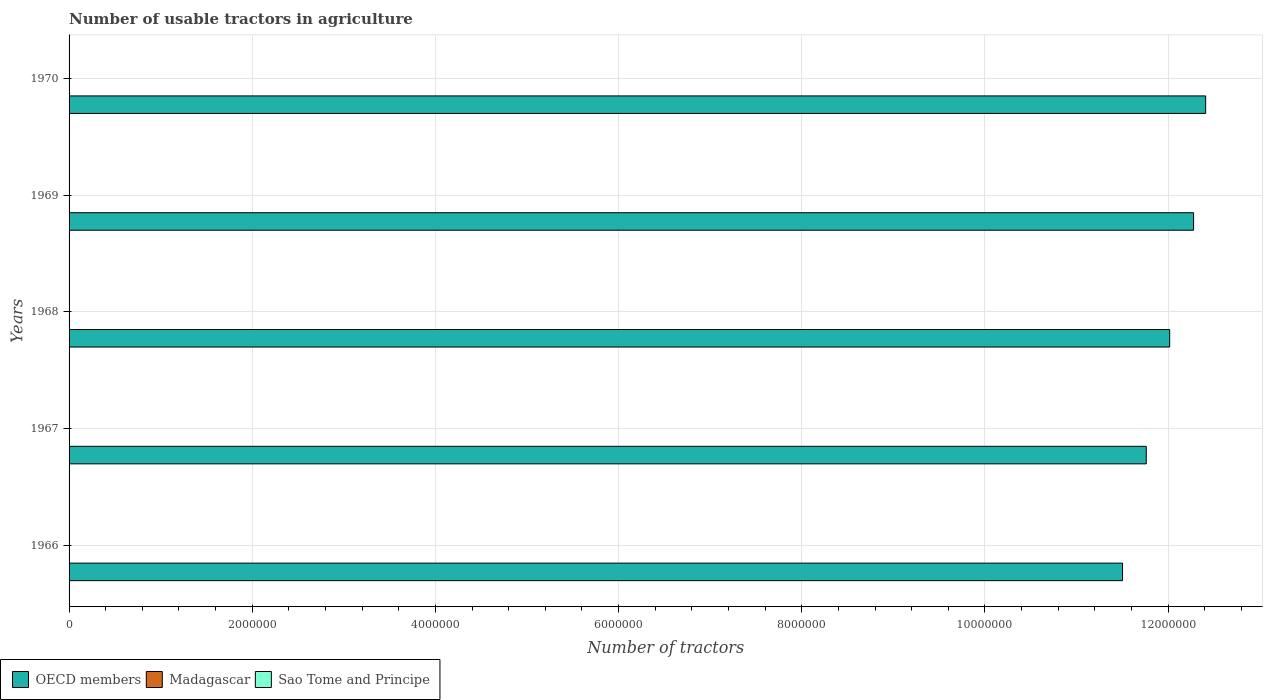How many different coloured bars are there?
Your response must be concise. 3. How many groups of bars are there?
Give a very brief answer. 5. Are the number of bars per tick equal to the number of legend labels?
Your answer should be compact. Yes. How many bars are there on the 1st tick from the bottom?
Offer a terse response. 3. What is the number of usable tractors in agriculture in Madagascar in 1969?
Provide a short and direct response. 2410. Across all years, what is the maximum number of usable tractors in agriculture in Sao Tome and Principe?
Give a very brief answer. 114. Across all years, what is the minimum number of usable tractors in agriculture in OECD members?
Make the answer very short. 1.15e+07. In which year was the number of usable tractors in agriculture in Sao Tome and Principe minimum?
Provide a succinct answer. 1966. What is the total number of usable tractors in agriculture in Madagascar in the graph?
Your answer should be compact. 1.11e+04. What is the difference between the number of usable tractors in agriculture in OECD members in 1970 and the number of usable tractors in agriculture in Madagascar in 1968?
Give a very brief answer. 1.24e+07. What is the average number of usable tractors in agriculture in Madagascar per year?
Offer a very short reply. 2223. In the year 1967, what is the difference between the number of usable tractors in agriculture in OECD members and number of usable tractors in agriculture in Madagascar?
Offer a terse response. 1.18e+07. What is the ratio of the number of usable tractors in agriculture in OECD members in 1968 to that in 1970?
Give a very brief answer. 0.97. Is the difference between the number of usable tractors in agriculture in OECD members in 1966 and 1968 greater than the difference between the number of usable tractors in agriculture in Madagascar in 1966 and 1968?
Provide a succinct answer. No. What is the difference between the highest and the second highest number of usable tractors in agriculture in Madagascar?
Your answer should be very brief. 5. What is the difference between the highest and the lowest number of usable tractors in agriculture in Madagascar?
Provide a short and direct response. 510. Is the sum of the number of usable tractors in agriculture in OECD members in 1967 and 1970 greater than the maximum number of usable tractors in agriculture in Madagascar across all years?
Your answer should be very brief. Yes. What does the 2nd bar from the top in 1967 represents?
Make the answer very short. Madagascar. What does the 1st bar from the bottom in 1969 represents?
Offer a terse response. OECD members. How many years are there in the graph?
Provide a short and direct response. 5. What is the difference between two consecutive major ticks on the X-axis?
Keep it short and to the point. 2.00e+06. Are the values on the major ticks of X-axis written in scientific E-notation?
Your response must be concise. No. Does the graph contain any zero values?
Provide a short and direct response. No. Does the graph contain grids?
Offer a terse response. Yes. Where does the legend appear in the graph?
Ensure brevity in your answer.  Bottom left. How many legend labels are there?
Provide a succinct answer. 3. How are the legend labels stacked?
Your answer should be compact. Horizontal. What is the title of the graph?
Make the answer very short. Number of usable tractors in agriculture. Does "Liechtenstein" appear as one of the legend labels in the graph?
Give a very brief answer. No. What is the label or title of the X-axis?
Offer a very short reply. Number of tractors. What is the Number of tractors of OECD members in 1966?
Keep it short and to the point. 1.15e+07. What is the Number of tractors of Madagascar in 1966?
Offer a terse response. 1900. What is the Number of tractors of Sao Tome and Principe in 1966?
Your answer should be compact. 60. What is the Number of tractors of OECD members in 1967?
Your answer should be very brief. 1.18e+07. What is the Number of tractors in Madagascar in 1967?
Ensure brevity in your answer.  2100. What is the Number of tractors of Sao Tome and Principe in 1967?
Provide a short and direct response. 80. What is the Number of tractors of OECD members in 1968?
Give a very brief answer. 1.20e+07. What is the Number of tractors of Madagascar in 1968?
Your response must be concise. 2300. What is the Number of tractors of Sao Tome and Principe in 1968?
Keep it short and to the point. 100. What is the Number of tractors of OECD members in 1969?
Provide a short and direct response. 1.23e+07. What is the Number of tractors of Madagascar in 1969?
Your answer should be very brief. 2410. What is the Number of tractors of Sao Tome and Principe in 1969?
Offer a terse response. 110. What is the Number of tractors of OECD members in 1970?
Your response must be concise. 1.24e+07. What is the Number of tractors of Madagascar in 1970?
Your answer should be very brief. 2405. What is the Number of tractors in Sao Tome and Principe in 1970?
Offer a terse response. 114. Across all years, what is the maximum Number of tractors in OECD members?
Make the answer very short. 1.24e+07. Across all years, what is the maximum Number of tractors of Madagascar?
Provide a succinct answer. 2410. Across all years, what is the maximum Number of tractors of Sao Tome and Principe?
Your answer should be compact. 114. Across all years, what is the minimum Number of tractors in OECD members?
Make the answer very short. 1.15e+07. Across all years, what is the minimum Number of tractors in Madagascar?
Provide a succinct answer. 1900. Across all years, what is the minimum Number of tractors of Sao Tome and Principe?
Keep it short and to the point. 60. What is the total Number of tractors in OECD members in the graph?
Your answer should be compact. 6.00e+07. What is the total Number of tractors of Madagascar in the graph?
Your answer should be very brief. 1.11e+04. What is the total Number of tractors in Sao Tome and Principe in the graph?
Offer a very short reply. 464. What is the difference between the Number of tractors of OECD members in 1966 and that in 1967?
Your answer should be very brief. -2.59e+05. What is the difference between the Number of tractors of Madagascar in 1966 and that in 1967?
Give a very brief answer. -200. What is the difference between the Number of tractors in OECD members in 1966 and that in 1968?
Your answer should be very brief. -5.15e+05. What is the difference between the Number of tractors in Madagascar in 1966 and that in 1968?
Offer a terse response. -400. What is the difference between the Number of tractors of OECD members in 1966 and that in 1969?
Your answer should be compact. -7.76e+05. What is the difference between the Number of tractors in Madagascar in 1966 and that in 1969?
Offer a very short reply. -510. What is the difference between the Number of tractors of Sao Tome and Principe in 1966 and that in 1969?
Your answer should be very brief. -50. What is the difference between the Number of tractors in OECD members in 1966 and that in 1970?
Offer a terse response. -9.08e+05. What is the difference between the Number of tractors of Madagascar in 1966 and that in 1970?
Make the answer very short. -505. What is the difference between the Number of tractors of Sao Tome and Principe in 1966 and that in 1970?
Provide a succinct answer. -54. What is the difference between the Number of tractors in OECD members in 1967 and that in 1968?
Give a very brief answer. -2.56e+05. What is the difference between the Number of tractors in Madagascar in 1967 and that in 1968?
Your answer should be very brief. -200. What is the difference between the Number of tractors in OECD members in 1967 and that in 1969?
Provide a short and direct response. -5.17e+05. What is the difference between the Number of tractors in Madagascar in 1967 and that in 1969?
Your response must be concise. -310. What is the difference between the Number of tractors in OECD members in 1967 and that in 1970?
Provide a short and direct response. -6.49e+05. What is the difference between the Number of tractors in Madagascar in 1967 and that in 1970?
Give a very brief answer. -305. What is the difference between the Number of tractors in Sao Tome and Principe in 1967 and that in 1970?
Ensure brevity in your answer.  -34. What is the difference between the Number of tractors of OECD members in 1968 and that in 1969?
Provide a short and direct response. -2.61e+05. What is the difference between the Number of tractors in Madagascar in 1968 and that in 1969?
Your response must be concise. -110. What is the difference between the Number of tractors in OECD members in 1968 and that in 1970?
Offer a terse response. -3.93e+05. What is the difference between the Number of tractors in Madagascar in 1968 and that in 1970?
Give a very brief answer. -105. What is the difference between the Number of tractors of OECD members in 1969 and that in 1970?
Keep it short and to the point. -1.32e+05. What is the difference between the Number of tractors in Madagascar in 1969 and that in 1970?
Make the answer very short. 5. What is the difference between the Number of tractors of OECD members in 1966 and the Number of tractors of Madagascar in 1967?
Provide a succinct answer. 1.15e+07. What is the difference between the Number of tractors in OECD members in 1966 and the Number of tractors in Sao Tome and Principe in 1967?
Offer a terse response. 1.15e+07. What is the difference between the Number of tractors of Madagascar in 1966 and the Number of tractors of Sao Tome and Principe in 1967?
Offer a terse response. 1820. What is the difference between the Number of tractors in OECD members in 1966 and the Number of tractors in Madagascar in 1968?
Provide a short and direct response. 1.15e+07. What is the difference between the Number of tractors in OECD members in 1966 and the Number of tractors in Sao Tome and Principe in 1968?
Provide a short and direct response. 1.15e+07. What is the difference between the Number of tractors of Madagascar in 1966 and the Number of tractors of Sao Tome and Principe in 1968?
Offer a terse response. 1800. What is the difference between the Number of tractors in OECD members in 1966 and the Number of tractors in Madagascar in 1969?
Your answer should be compact. 1.15e+07. What is the difference between the Number of tractors of OECD members in 1966 and the Number of tractors of Sao Tome and Principe in 1969?
Offer a terse response. 1.15e+07. What is the difference between the Number of tractors of Madagascar in 1966 and the Number of tractors of Sao Tome and Principe in 1969?
Keep it short and to the point. 1790. What is the difference between the Number of tractors in OECD members in 1966 and the Number of tractors in Madagascar in 1970?
Your answer should be compact. 1.15e+07. What is the difference between the Number of tractors in OECD members in 1966 and the Number of tractors in Sao Tome and Principe in 1970?
Offer a terse response. 1.15e+07. What is the difference between the Number of tractors in Madagascar in 1966 and the Number of tractors in Sao Tome and Principe in 1970?
Your response must be concise. 1786. What is the difference between the Number of tractors in OECD members in 1967 and the Number of tractors in Madagascar in 1968?
Make the answer very short. 1.18e+07. What is the difference between the Number of tractors of OECD members in 1967 and the Number of tractors of Sao Tome and Principe in 1968?
Your answer should be compact. 1.18e+07. What is the difference between the Number of tractors of Madagascar in 1967 and the Number of tractors of Sao Tome and Principe in 1968?
Keep it short and to the point. 2000. What is the difference between the Number of tractors in OECD members in 1967 and the Number of tractors in Madagascar in 1969?
Your answer should be very brief. 1.18e+07. What is the difference between the Number of tractors of OECD members in 1967 and the Number of tractors of Sao Tome and Principe in 1969?
Provide a short and direct response. 1.18e+07. What is the difference between the Number of tractors of Madagascar in 1967 and the Number of tractors of Sao Tome and Principe in 1969?
Provide a succinct answer. 1990. What is the difference between the Number of tractors in OECD members in 1967 and the Number of tractors in Madagascar in 1970?
Offer a terse response. 1.18e+07. What is the difference between the Number of tractors in OECD members in 1967 and the Number of tractors in Sao Tome and Principe in 1970?
Provide a succinct answer. 1.18e+07. What is the difference between the Number of tractors in Madagascar in 1967 and the Number of tractors in Sao Tome and Principe in 1970?
Make the answer very short. 1986. What is the difference between the Number of tractors of OECD members in 1968 and the Number of tractors of Madagascar in 1969?
Ensure brevity in your answer.  1.20e+07. What is the difference between the Number of tractors of OECD members in 1968 and the Number of tractors of Sao Tome and Principe in 1969?
Your response must be concise. 1.20e+07. What is the difference between the Number of tractors of Madagascar in 1968 and the Number of tractors of Sao Tome and Principe in 1969?
Give a very brief answer. 2190. What is the difference between the Number of tractors in OECD members in 1968 and the Number of tractors in Madagascar in 1970?
Your answer should be compact. 1.20e+07. What is the difference between the Number of tractors of OECD members in 1968 and the Number of tractors of Sao Tome and Principe in 1970?
Make the answer very short. 1.20e+07. What is the difference between the Number of tractors of Madagascar in 1968 and the Number of tractors of Sao Tome and Principe in 1970?
Make the answer very short. 2186. What is the difference between the Number of tractors of OECD members in 1969 and the Number of tractors of Madagascar in 1970?
Offer a very short reply. 1.23e+07. What is the difference between the Number of tractors of OECD members in 1969 and the Number of tractors of Sao Tome and Principe in 1970?
Your answer should be very brief. 1.23e+07. What is the difference between the Number of tractors in Madagascar in 1969 and the Number of tractors in Sao Tome and Principe in 1970?
Your answer should be very brief. 2296. What is the average Number of tractors in OECD members per year?
Offer a terse response. 1.20e+07. What is the average Number of tractors of Madagascar per year?
Offer a very short reply. 2223. What is the average Number of tractors in Sao Tome and Principe per year?
Ensure brevity in your answer.  92.8. In the year 1966, what is the difference between the Number of tractors in OECD members and Number of tractors in Madagascar?
Make the answer very short. 1.15e+07. In the year 1966, what is the difference between the Number of tractors in OECD members and Number of tractors in Sao Tome and Principe?
Provide a short and direct response. 1.15e+07. In the year 1966, what is the difference between the Number of tractors in Madagascar and Number of tractors in Sao Tome and Principe?
Offer a terse response. 1840. In the year 1967, what is the difference between the Number of tractors of OECD members and Number of tractors of Madagascar?
Your answer should be very brief. 1.18e+07. In the year 1967, what is the difference between the Number of tractors in OECD members and Number of tractors in Sao Tome and Principe?
Provide a succinct answer. 1.18e+07. In the year 1967, what is the difference between the Number of tractors of Madagascar and Number of tractors of Sao Tome and Principe?
Your answer should be compact. 2020. In the year 1968, what is the difference between the Number of tractors of OECD members and Number of tractors of Madagascar?
Your answer should be compact. 1.20e+07. In the year 1968, what is the difference between the Number of tractors of OECD members and Number of tractors of Sao Tome and Principe?
Make the answer very short. 1.20e+07. In the year 1968, what is the difference between the Number of tractors in Madagascar and Number of tractors in Sao Tome and Principe?
Offer a terse response. 2200. In the year 1969, what is the difference between the Number of tractors in OECD members and Number of tractors in Madagascar?
Offer a terse response. 1.23e+07. In the year 1969, what is the difference between the Number of tractors of OECD members and Number of tractors of Sao Tome and Principe?
Ensure brevity in your answer.  1.23e+07. In the year 1969, what is the difference between the Number of tractors in Madagascar and Number of tractors in Sao Tome and Principe?
Provide a short and direct response. 2300. In the year 1970, what is the difference between the Number of tractors of OECD members and Number of tractors of Madagascar?
Provide a succinct answer. 1.24e+07. In the year 1970, what is the difference between the Number of tractors in OECD members and Number of tractors in Sao Tome and Principe?
Give a very brief answer. 1.24e+07. In the year 1970, what is the difference between the Number of tractors of Madagascar and Number of tractors of Sao Tome and Principe?
Keep it short and to the point. 2291. What is the ratio of the Number of tractors in OECD members in 1966 to that in 1967?
Your answer should be very brief. 0.98. What is the ratio of the Number of tractors of Madagascar in 1966 to that in 1967?
Your response must be concise. 0.9. What is the ratio of the Number of tractors in Sao Tome and Principe in 1966 to that in 1967?
Your answer should be very brief. 0.75. What is the ratio of the Number of tractors of OECD members in 1966 to that in 1968?
Your answer should be compact. 0.96. What is the ratio of the Number of tractors in Madagascar in 1966 to that in 1968?
Offer a very short reply. 0.83. What is the ratio of the Number of tractors in OECD members in 1966 to that in 1969?
Make the answer very short. 0.94. What is the ratio of the Number of tractors of Madagascar in 1966 to that in 1969?
Ensure brevity in your answer.  0.79. What is the ratio of the Number of tractors in Sao Tome and Principe in 1966 to that in 1969?
Ensure brevity in your answer.  0.55. What is the ratio of the Number of tractors in OECD members in 1966 to that in 1970?
Give a very brief answer. 0.93. What is the ratio of the Number of tractors of Madagascar in 1966 to that in 1970?
Keep it short and to the point. 0.79. What is the ratio of the Number of tractors in Sao Tome and Principe in 1966 to that in 1970?
Give a very brief answer. 0.53. What is the ratio of the Number of tractors of OECD members in 1967 to that in 1968?
Give a very brief answer. 0.98. What is the ratio of the Number of tractors of Madagascar in 1967 to that in 1968?
Your answer should be very brief. 0.91. What is the ratio of the Number of tractors in OECD members in 1967 to that in 1969?
Offer a terse response. 0.96. What is the ratio of the Number of tractors in Madagascar in 1967 to that in 1969?
Provide a short and direct response. 0.87. What is the ratio of the Number of tractors in Sao Tome and Principe in 1967 to that in 1969?
Your answer should be compact. 0.73. What is the ratio of the Number of tractors of OECD members in 1967 to that in 1970?
Provide a succinct answer. 0.95. What is the ratio of the Number of tractors of Madagascar in 1967 to that in 1970?
Keep it short and to the point. 0.87. What is the ratio of the Number of tractors of Sao Tome and Principe in 1967 to that in 1970?
Offer a terse response. 0.7. What is the ratio of the Number of tractors in OECD members in 1968 to that in 1969?
Keep it short and to the point. 0.98. What is the ratio of the Number of tractors in Madagascar in 1968 to that in 1969?
Provide a succinct answer. 0.95. What is the ratio of the Number of tractors of OECD members in 1968 to that in 1970?
Offer a terse response. 0.97. What is the ratio of the Number of tractors of Madagascar in 1968 to that in 1970?
Keep it short and to the point. 0.96. What is the ratio of the Number of tractors in Sao Tome and Principe in 1968 to that in 1970?
Give a very brief answer. 0.88. What is the ratio of the Number of tractors of OECD members in 1969 to that in 1970?
Offer a terse response. 0.99. What is the ratio of the Number of tractors of Madagascar in 1969 to that in 1970?
Give a very brief answer. 1. What is the ratio of the Number of tractors of Sao Tome and Principe in 1969 to that in 1970?
Your response must be concise. 0.96. What is the difference between the highest and the second highest Number of tractors of OECD members?
Offer a very short reply. 1.32e+05. What is the difference between the highest and the lowest Number of tractors in OECD members?
Provide a short and direct response. 9.08e+05. What is the difference between the highest and the lowest Number of tractors of Madagascar?
Your response must be concise. 510. What is the difference between the highest and the lowest Number of tractors of Sao Tome and Principe?
Your answer should be compact. 54. 